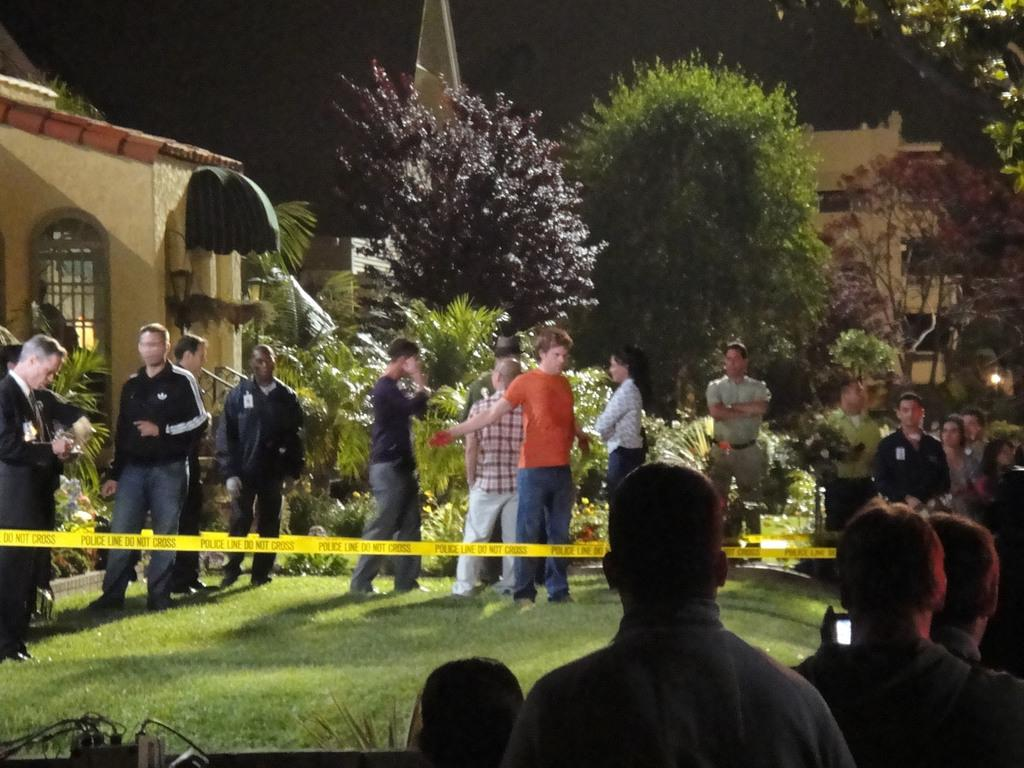What are the people in the image doing? The people in the image are standing in the center. What can be seen in the background of the image? There are buildings, trees, and the sky visible in the background. Can you describe the light present in the image? Yes, there is a light present in the image. What type of mine can be seen in the image? There is no mine present in the image. How does the stocking increase the efficiency of the people in the image? There is no mention of a stocking in the image, and it does not affect the efficiency of the people. 